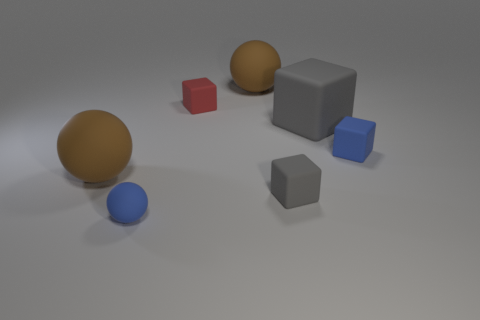Are there any blue rubber balls behind the brown sphere that is in front of the red rubber thing?
Offer a very short reply. No. Is the number of blue rubber spheres that are behind the red cube less than the number of large rubber things to the left of the small gray cube?
Offer a very short reply. Yes. Is there any other thing that has the same size as the red block?
Provide a succinct answer. Yes. There is a tiny gray object; what shape is it?
Give a very brief answer. Cube. What is the material of the brown ball on the left side of the tiny blue ball?
Keep it short and to the point. Rubber. What is the size of the brown rubber sphere that is in front of the big brown matte ball that is on the right side of the blue matte thing that is to the left of the tiny red object?
Give a very brief answer. Large. Are the gray cube that is in front of the big gray matte block and the block left of the small gray rubber cube made of the same material?
Make the answer very short. Yes. What number of other objects are there of the same color as the large matte cube?
Make the answer very short. 1. What number of things are big brown matte things that are to the left of the small red rubber object or brown rubber things left of the tiny blue matte sphere?
Your answer should be very brief. 1. There is a gray rubber cube that is behind the large sphere that is left of the small blue sphere; how big is it?
Keep it short and to the point. Large. 